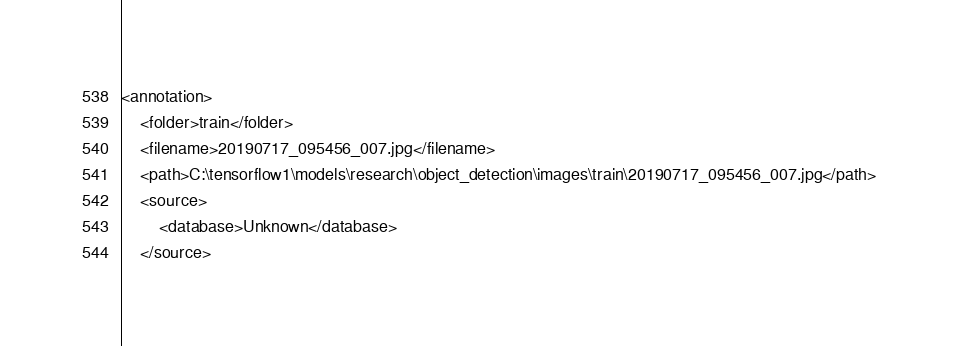<code> <loc_0><loc_0><loc_500><loc_500><_XML_><annotation>
	<folder>train</folder>
	<filename>20190717_095456_007.jpg</filename>
	<path>C:\tensorflow1\models\research\object_detection\images\train\20190717_095456_007.jpg</path>
	<source>
		<database>Unknown</database>
	</source></code> 